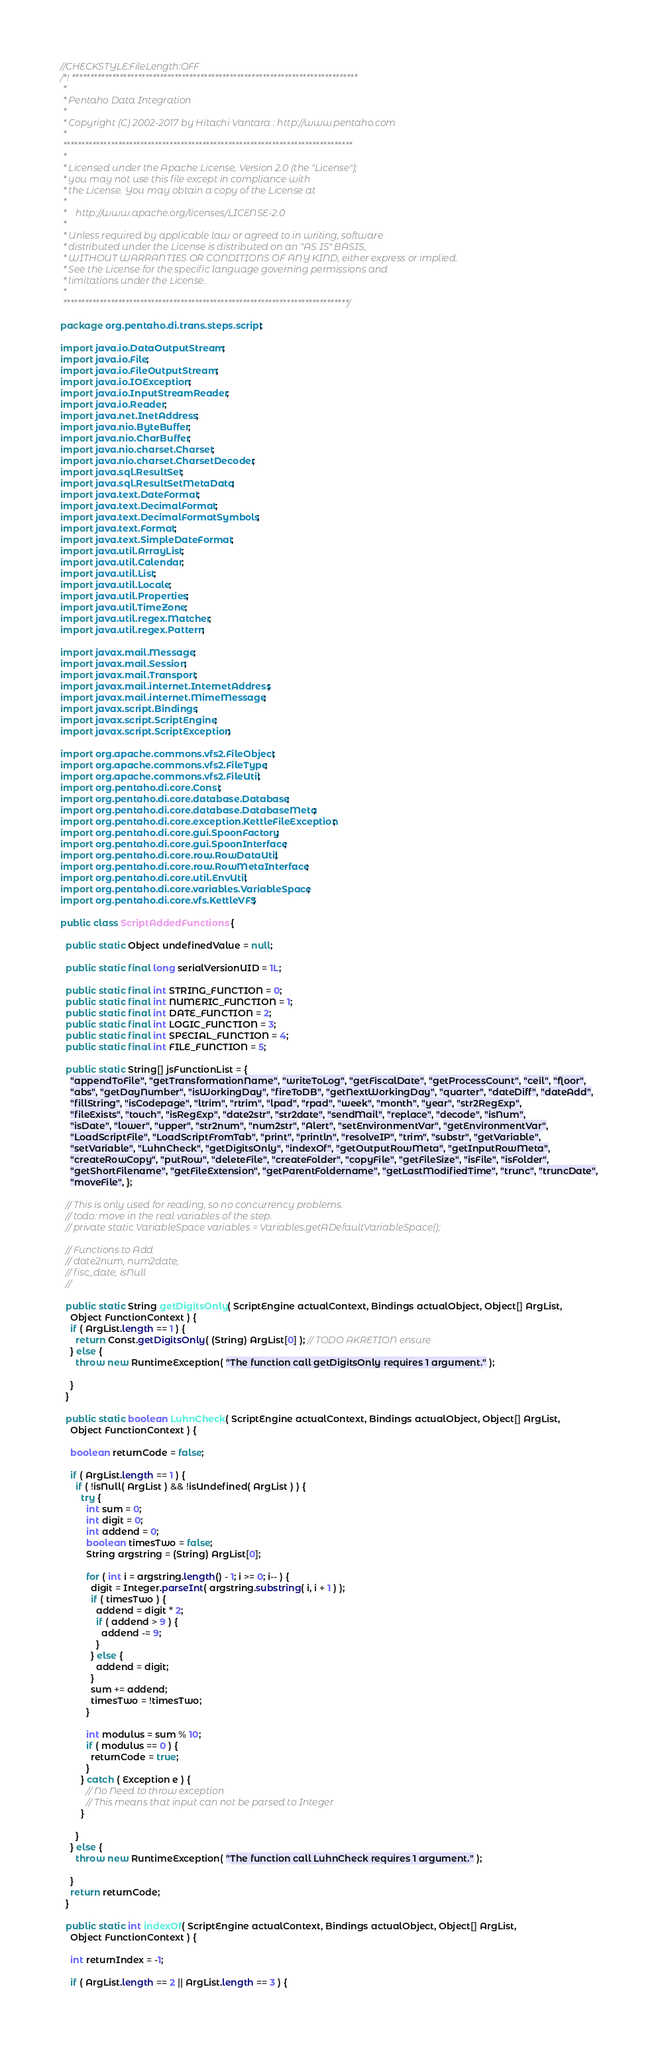<code> <loc_0><loc_0><loc_500><loc_500><_Java_>//CHECKSTYLE:FileLength:OFF
/*! ******************************************************************************
 *
 * Pentaho Data Integration
 *
 * Copyright (C) 2002-2017 by Hitachi Vantara : http://www.pentaho.com
 *
 *******************************************************************************
 *
 * Licensed under the Apache License, Version 2.0 (the "License");
 * you may not use this file except in compliance with
 * the License. You may obtain a copy of the License at
 *
 *    http://www.apache.org/licenses/LICENSE-2.0
 *
 * Unless required by applicable law or agreed to in writing, software
 * distributed under the License is distributed on an "AS IS" BASIS,
 * WITHOUT WARRANTIES OR CONDITIONS OF ANY KIND, either express or implied.
 * See the License for the specific language governing permissions and
 * limitations under the License.
 *
 ******************************************************************************/

package org.pentaho.di.trans.steps.script;

import java.io.DataOutputStream;
import java.io.File;
import java.io.FileOutputStream;
import java.io.IOException;
import java.io.InputStreamReader;
import java.io.Reader;
import java.net.InetAddress;
import java.nio.ByteBuffer;
import java.nio.CharBuffer;
import java.nio.charset.Charset;
import java.nio.charset.CharsetDecoder;
import java.sql.ResultSet;
import java.sql.ResultSetMetaData;
import java.text.DateFormat;
import java.text.DecimalFormat;
import java.text.DecimalFormatSymbols;
import java.text.Format;
import java.text.SimpleDateFormat;
import java.util.ArrayList;
import java.util.Calendar;
import java.util.List;
import java.util.Locale;
import java.util.Properties;
import java.util.TimeZone;
import java.util.regex.Matcher;
import java.util.regex.Pattern;

import javax.mail.Message;
import javax.mail.Session;
import javax.mail.Transport;
import javax.mail.internet.InternetAddress;
import javax.mail.internet.MimeMessage;
import javax.script.Bindings;
import javax.script.ScriptEngine;
import javax.script.ScriptException;

import org.apache.commons.vfs2.FileObject;
import org.apache.commons.vfs2.FileType;
import org.apache.commons.vfs2.FileUtil;
import org.pentaho.di.core.Const;
import org.pentaho.di.core.database.Database;
import org.pentaho.di.core.database.DatabaseMeta;
import org.pentaho.di.core.exception.KettleFileException;
import org.pentaho.di.core.gui.SpoonFactory;
import org.pentaho.di.core.gui.SpoonInterface;
import org.pentaho.di.core.row.RowDataUtil;
import org.pentaho.di.core.row.RowMetaInterface;
import org.pentaho.di.core.util.EnvUtil;
import org.pentaho.di.core.variables.VariableSpace;
import org.pentaho.di.core.vfs.KettleVFS;

public class ScriptAddedFunctions {

  public static Object undefinedValue = null;

  public static final long serialVersionUID = 1L;

  public static final int STRING_FUNCTION = 0;
  public static final int NUMERIC_FUNCTION = 1;
  public static final int DATE_FUNCTION = 2;
  public static final int LOGIC_FUNCTION = 3;
  public static final int SPECIAL_FUNCTION = 4;
  public static final int FILE_FUNCTION = 5;

  public static String[] jsFunctionList = {
    "appendToFile", "getTransformationName", "writeToLog", "getFiscalDate", "getProcessCount", "ceil", "floor",
    "abs", "getDayNumber", "isWorkingDay", "fireToDB", "getNextWorkingDay", "quarter", "dateDiff", "dateAdd",
    "fillString", "isCodepage", "ltrim", "rtrim", "lpad", "rpad", "week", "month", "year", "str2RegExp",
    "fileExists", "touch", "isRegExp", "date2str", "str2date", "sendMail", "replace", "decode", "isNum",
    "isDate", "lower", "upper", "str2num", "num2str", "Alert", "setEnvironmentVar", "getEnvironmentVar",
    "LoadScriptFile", "LoadScriptFromTab", "print", "println", "resolveIP", "trim", "substr", "getVariable",
    "setVariable", "LuhnCheck", "getDigitsOnly", "indexOf", "getOutputRowMeta", "getInputRowMeta",
    "createRowCopy", "putRow", "deleteFile", "createFolder", "copyFile", "getFileSize", "isFile", "isFolder",
    "getShortFilename", "getFileExtension", "getParentFoldername", "getLastModifiedTime", "trunc", "truncDate",
    "moveFile", };

  // This is only used for reading, so no concurrency problems.
  // todo: move in the real variables of the step.
  // private static VariableSpace variables = Variables.getADefaultVariableSpace();

  // Functions to Add
  // date2num, num2date,
  // fisc_date, isNull
  //

  public static String getDigitsOnly( ScriptEngine actualContext, Bindings actualObject, Object[] ArgList,
    Object FunctionContext ) {
    if ( ArgList.length == 1 ) {
      return Const.getDigitsOnly( (String) ArgList[0] ); // TODO AKRETION ensure
    } else {
      throw new RuntimeException( "The function call getDigitsOnly requires 1 argument." );

    }
  }

  public static boolean LuhnCheck( ScriptEngine actualContext, Bindings actualObject, Object[] ArgList,
    Object FunctionContext ) {

    boolean returnCode = false;

    if ( ArgList.length == 1 ) {
      if ( !isNull( ArgList ) && !isUndefined( ArgList ) ) {
        try {
          int sum = 0;
          int digit = 0;
          int addend = 0;
          boolean timesTwo = false;
          String argstring = (String) ArgList[0];

          for ( int i = argstring.length() - 1; i >= 0; i-- ) {
            digit = Integer.parseInt( argstring.substring( i, i + 1 ) );
            if ( timesTwo ) {
              addend = digit * 2;
              if ( addend > 9 ) {
                addend -= 9;
              }
            } else {
              addend = digit;
            }
            sum += addend;
            timesTwo = !timesTwo;
          }

          int modulus = sum % 10;
          if ( modulus == 0 ) {
            returnCode = true;
          }
        } catch ( Exception e ) {
          // No Need to throw exception
          // This means that input can not be parsed to Integer
        }

      }
    } else {
      throw new RuntimeException( "The function call LuhnCheck requires 1 argument." );

    }
    return returnCode;
  }

  public static int indexOf( ScriptEngine actualContext, Bindings actualObject, Object[] ArgList,
    Object FunctionContext ) {

    int returnIndex = -1;

    if ( ArgList.length == 2 || ArgList.length == 3 ) {</code> 